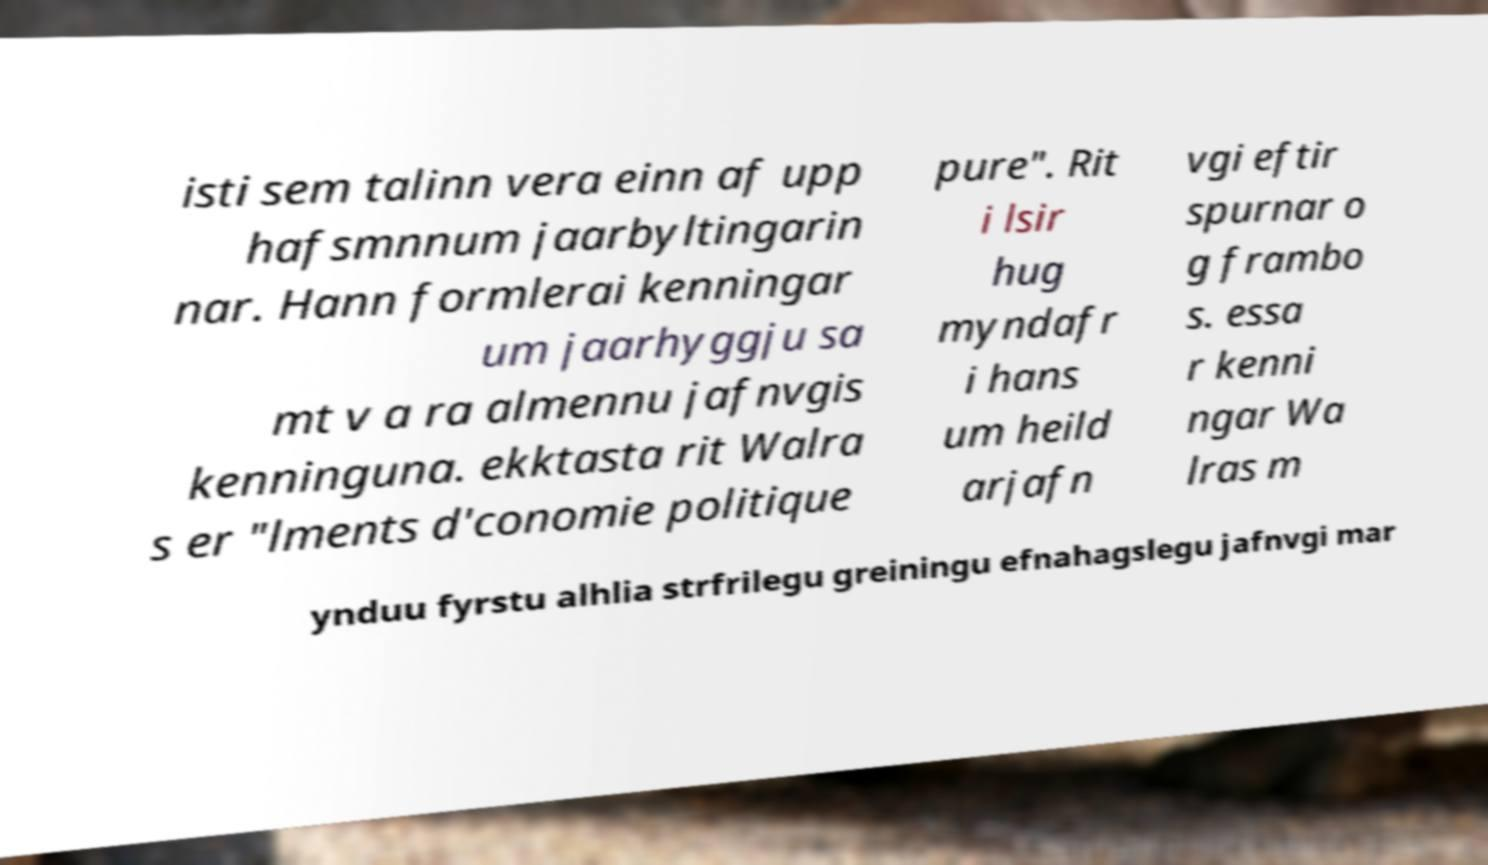For documentation purposes, I need the text within this image transcribed. Could you provide that? isti sem talinn vera einn af upp hafsmnnum jaarbyltingarin nar. Hann formlerai kenningar um jaarhyggju sa mt v a ra almennu jafnvgis kenninguna. ekktasta rit Walra s er "lments d'conomie politique pure". Rit i lsir hug myndafr i hans um heild arjafn vgi eftir spurnar o g frambo s. essa r kenni ngar Wa lras m ynduu fyrstu alhlia strfrilegu greiningu efnahagslegu jafnvgi mar 